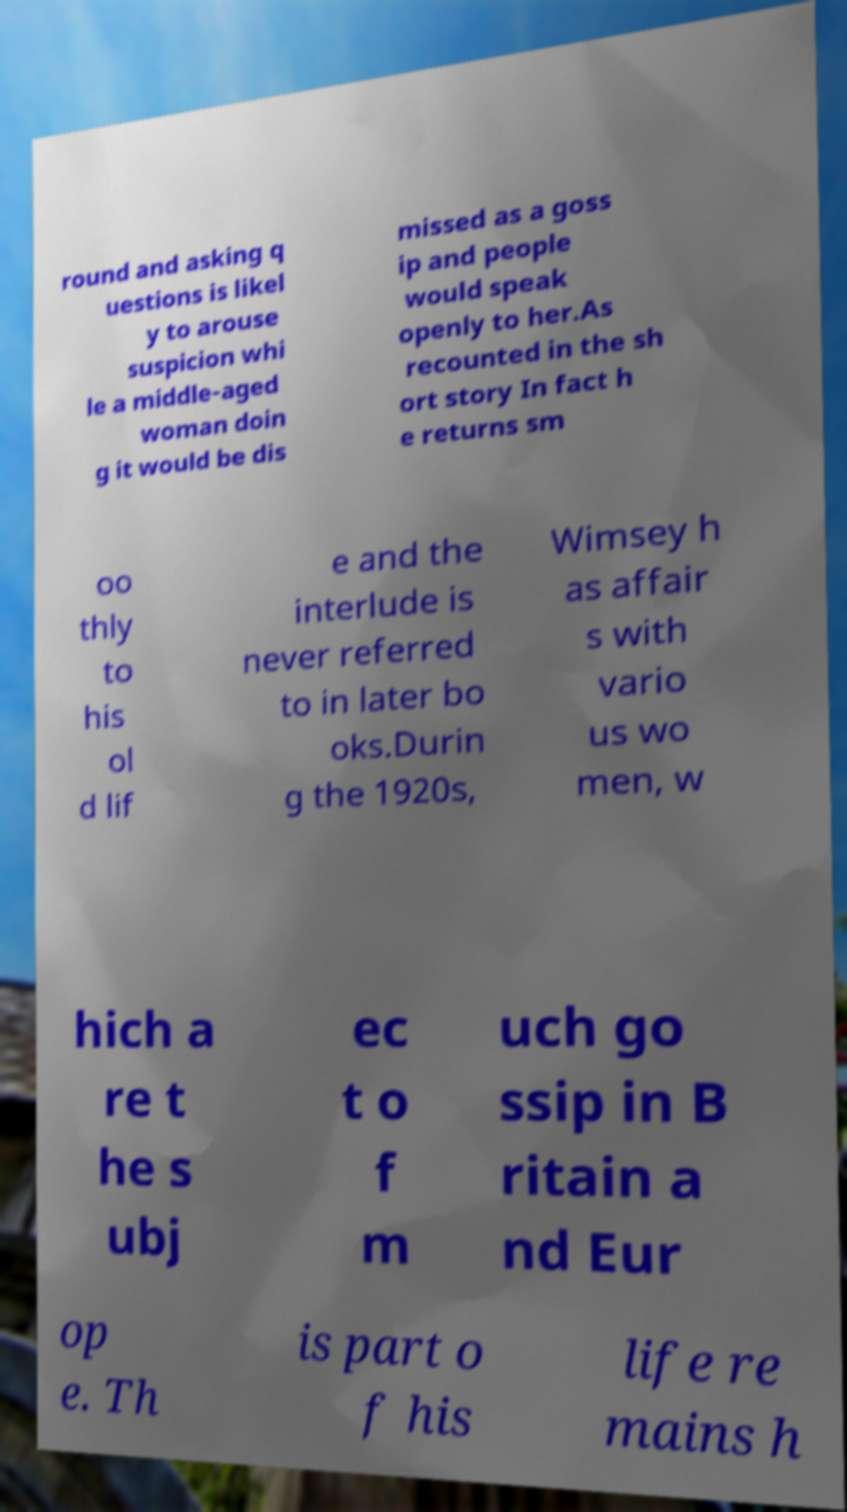Please identify and transcribe the text found in this image. round and asking q uestions is likel y to arouse suspicion whi le a middle-aged woman doin g it would be dis missed as a goss ip and people would speak openly to her.As recounted in the sh ort story In fact h e returns sm oo thly to his ol d lif e and the interlude is never referred to in later bo oks.Durin g the 1920s, Wimsey h as affair s with vario us wo men, w hich a re t he s ubj ec t o f m uch go ssip in B ritain a nd Eur op e. Th is part o f his life re mains h 